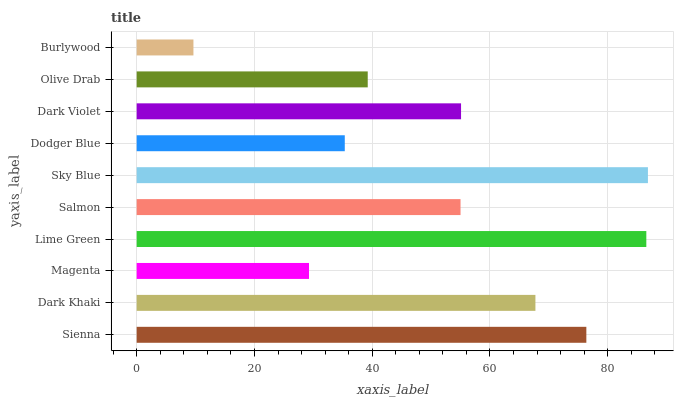Is Burlywood the minimum?
Answer yes or no. Yes. Is Sky Blue the maximum?
Answer yes or no. Yes. Is Dark Khaki the minimum?
Answer yes or no. No. Is Dark Khaki the maximum?
Answer yes or no. No. Is Sienna greater than Dark Khaki?
Answer yes or no. Yes. Is Dark Khaki less than Sienna?
Answer yes or no. Yes. Is Dark Khaki greater than Sienna?
Answer yes or no. No. Is Sienna less than Dark Khaki?
Answer yes or no. No. Is Dark Violet the high median?
Answer yes or no. Yes. Is Salmon the low median?
Answer yes or no. Yes. Is Sky Blue the high median?
Answer yes or no. No. Is Sky Blue the low median?
Answer yes or no. No. 